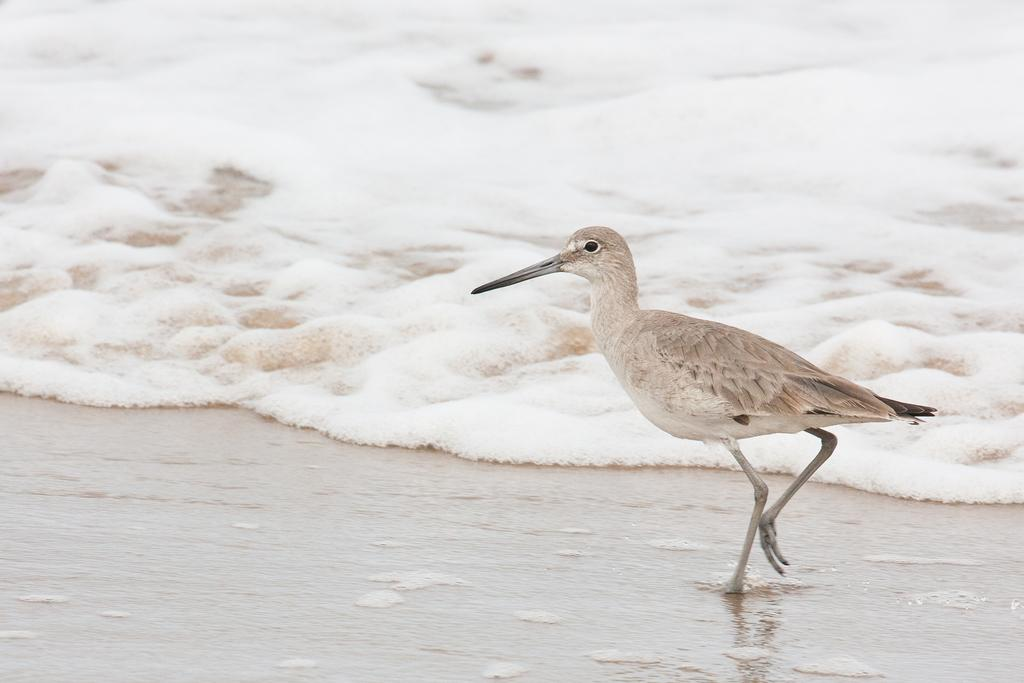What type of animal can be seen on the right side of the image? There is a bird on the right side of the image. What natural feature is visible in the background of the image? There is an ocean visible in the background of the image. What type of terrain is visible at the bottom of the image? There is soil visible at the bottom of the image. How many legs does the hill have in the image? There is no hill present in the image, and therefore no legs can be counted. 